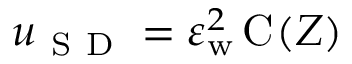Convert formula to latex. <formula><loc_0><loc_0><loc_500><loc_500>u _ { S D } = \varepsilon _ { w } ^ { 2 } \, C ( Z )</formula> 